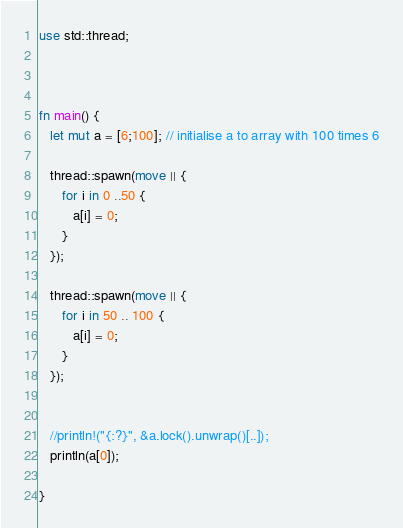Convert code to text. <code><loc_0><loc_0><loc_500><loc_500><_Rust_>use std::thread;



fn main() {
   let mut a = [6;100]; // initialise a to array with 100 times 6

   thread::spawn(move || {
      for i in 0 ..50 {
         a[i] = 0;
      }
   });

   thread::spawn(move || {
      for i in 50 .. 100 {
         a[i] = 0;
      }
   });

   
   //println!("{:?}", &a.lock().unwrap()[..]);
   println(a[0]);

}
</code> 